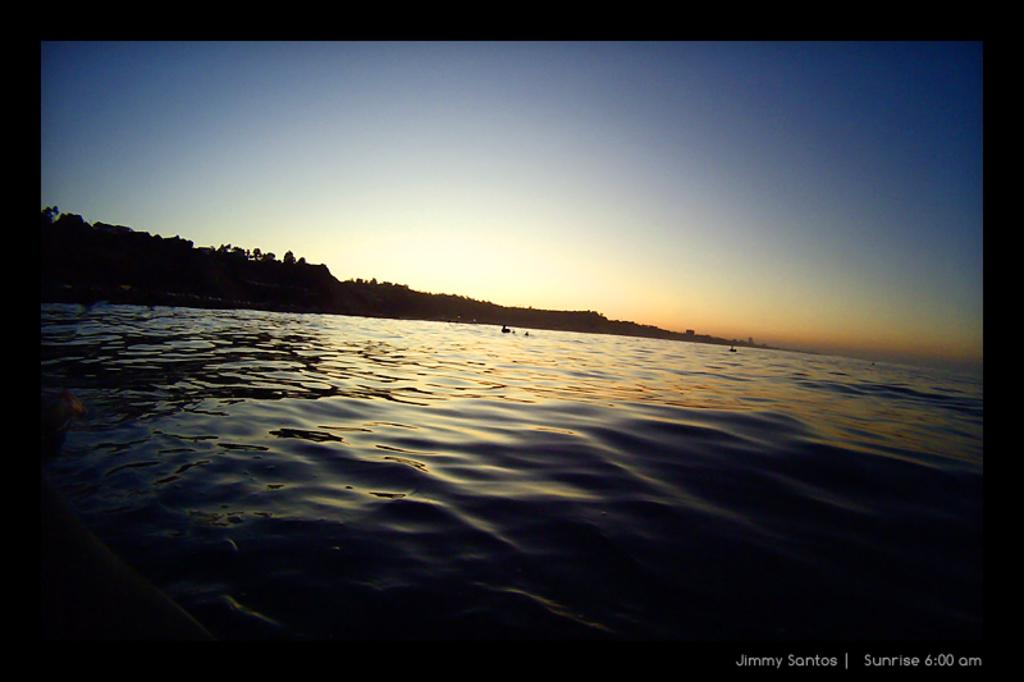What is in front of the image? There is water in front of the image. What can be seen in the background of the image? The sky is visible in the background of the image. Is there any additional information or branding present in the image? Yes, there is a watermark in the bottom right corner of the image. How many centimeters of string can be seen in the image? There is no string present in the image. Is there any wound visible in the image? There is no wound visible in the image. 